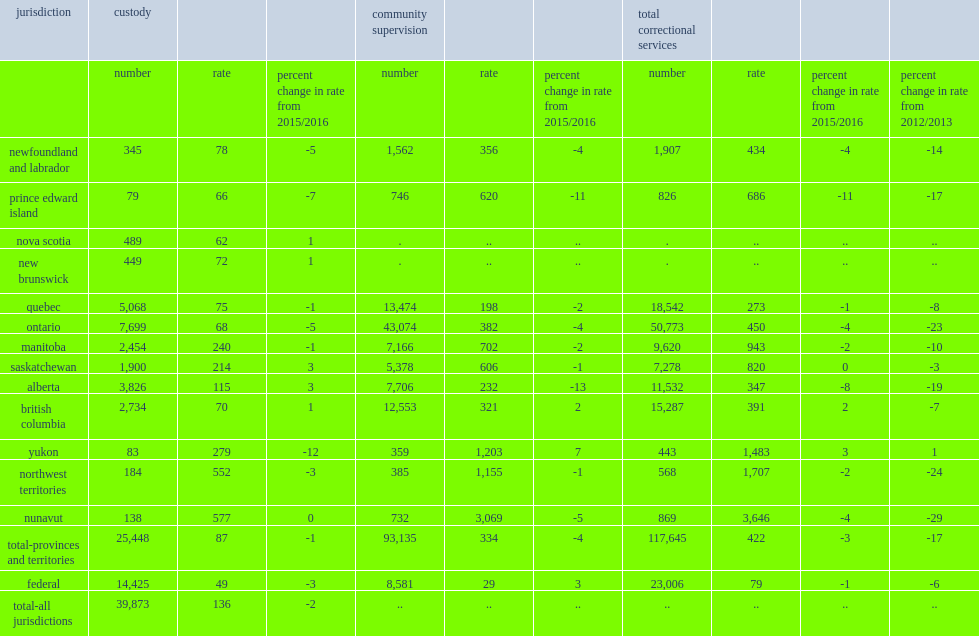What is the rate do correctional services represent of offenders per 100,000 adult population? 422.0. Correctional services represent a rate of 422 offenders per 100,000 adult population, what is a decline from the previous year? 3. Correctional services represent a rate of 422 offenders per 100,000 adult population, what is a decrease from 2012/2013? 17. What was the number of correctional service canada supervised an average of adult offenders in a custody or a community program in 2016/2017? 23006.0. Correctional service canada supervised an average of 23,006 adult offenders in a custody or a community program in 2016/2017, what was the rate of representing offenders per 100,000 adult population? 79.0. Correctional service canada supervised an average of 23,006 adult offenders in a custody or a community program in 2016/2017, what was a decrease from the previous year? 1. Correctional service canada supervised an average of 23,006 adult offenders in a custody or a community program in 2016/2017, what was a decline from five years earlier? 6. How many percent did prince edward island have the largest decrease at? -11.0. How many percent did alberta island have the second-largest decrease at? -8.0. As with previous years, how many percent of adults in provincial and territorial correctional services in 2016/2017 were supervised in the community? 79.0. On an average day in 2016/2017, how many adults in custody including provincial/territorial and federal custody? 39873.0. How many adults does custody translate into an adult incarceration rate of adults per 100,000 adult population? 136.0. Custody translates into an adult incarceration rate of 136 adults per 100,000 adult population, what was the percent of decrease from 2015/2016? 2. What was a total of adults in provincial and territorial custody in 2016/2017? 25448.0. What was a total of adults in federal custody on an average day in 2016/2017? 14425.0. What was the rate of manitoba which recorded the highest incarceration rate per 100,000 adult population? 240.0. What was the rate of nova scotia which recorded the lowest incarceration rate per 100,000 adult population? 62.0. 